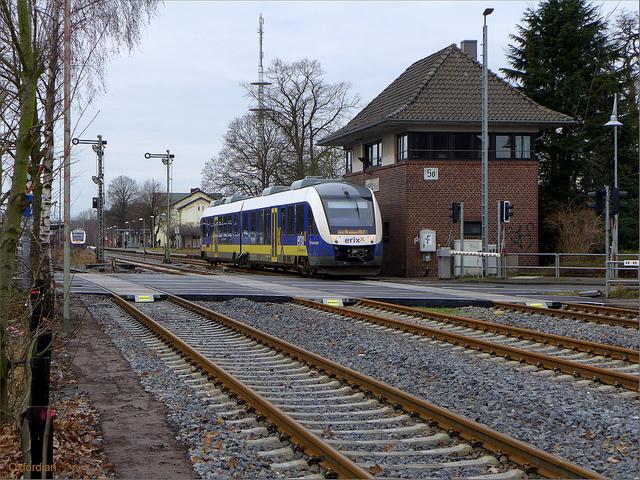Is the train moving?
Concise answer only. No. How many tracks run here?
Answer briefly. 3. What is at the station?
Keep it brief. Train. What colors detail the train?
Concise answer only. Yellow. Will these trees die soon?
Be succinct. No. 